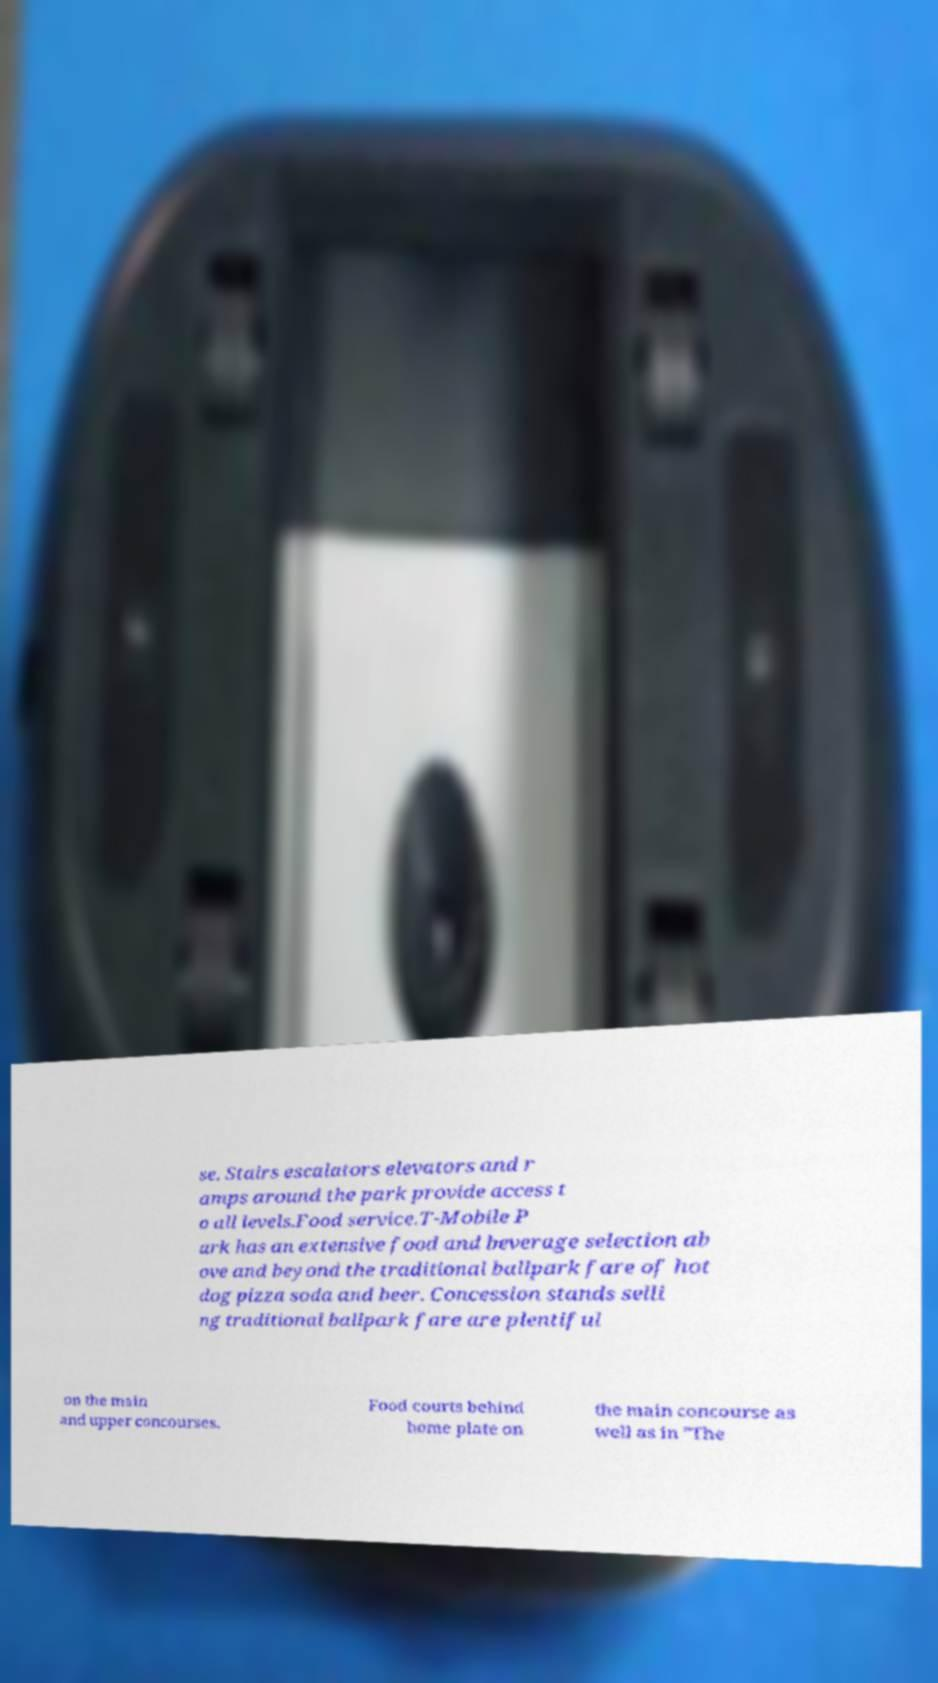What messages or text are displayed in this image? I need them in a readable, typed format. se. Stairs escalators elevators and r amps around the park provide access t o all levels.Food service.T-Mobile P ark has an extensive food and beverage selection ab ove and beyond the traditional ballpark fare of hot dog pizza soda and beer. Concession stands selli ng traditional ballpark fare are plentiful on the main and upper concourses. Food courts behind home plate on the main concourse as well as in "The 